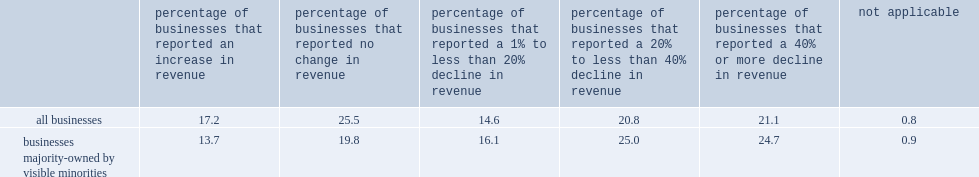Parse the table in full. {'header': ['', 'percentage of businesses that reported an increase in revenue', 'percentage of businesses that reported no change in revenue', 'percentage of businesses that reported a 1% to less than 20% decline in revenue', 'percentage of businesses that reported a 20% to less than 40% decline in revenue', 'percentage of businesses that reported a 40% or more decline in revenue', 'not applicable'], 'rows': [['all businesses', '17.2', '25.5', '14.6', '20.8', '21.1', '0.8'], ['businesses majority-owned by visible minorities', '13.7', '19.8', '16.1', '25.0', '24.7', '0.9']]} What was the percentage of businesses majority-owned by visible minorities reported a decrease in revenue of 40% or more? 24.7. What was the percentage of all businesses in canada said the same? 21.1. What was the percentage of businesses majority-owned by visible minorities reported no change in revenues? 19.8. What was the percentage of all businesses in canada reported no change in revenues? 25.5. What was the percentage of businesses majority-owned by visible minorities reported an increase in revenue? 13.7. What was the percentage of businesses majority-owned by visible minorities reported a decrease in revenue of 40% or more? 24.7. What was the percentage of all businesses in canada reported a decrease in revenue of 40% or more? 21.1. What was the percentage of businesses majority-owned by visible minorities reported no change in revenues? 19.8. What was the percentage of all businesses in canada reported no change in revenues? 25.5. What was the percentage of businesses majority-owned by visible minorities reported an increase in revenue? 13.7. 